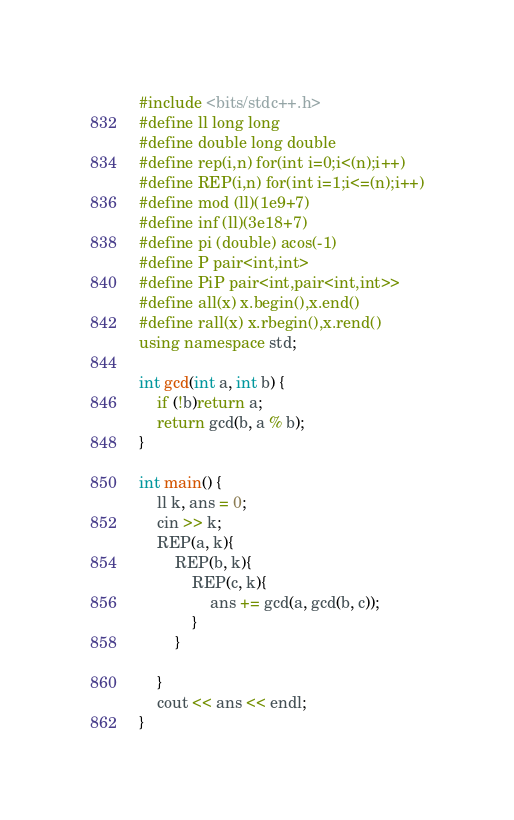Convert code to text. <code><loc_0><loc_0><loc_500><loc_500><_C++_>#include <bits/stdc++.h>
#define ll long long
#define double long double
#define rep(i,n) for(int i=0;i<(n);i++)
#define REP(i,n) for(int i=1;i<=(n);i++)
#define mod (ll)(1e9+7)
#define inf (ll)(3e18+7)
#define pi (double) acos(-1)
#define P pair<int,int>
#define PiP pair<int,pair<int,int>>
#define all(x) x.begin(),x.end()
#define rall(x) x.rbegin(),x.rend()
using namespace std;

int gcd(int a, int b) {
	if (!b)return a;
	return gcd(b, a % b);
}

int main() {
    ll k, ans = 0;
    cin >> k;
    REP(a, k){
        REP(b, k){
            REP(c, k){
                ans += gcd(a, gcd(b, c));
            }
        }
    
    }
    cout << ans << endl;
}   </code> 